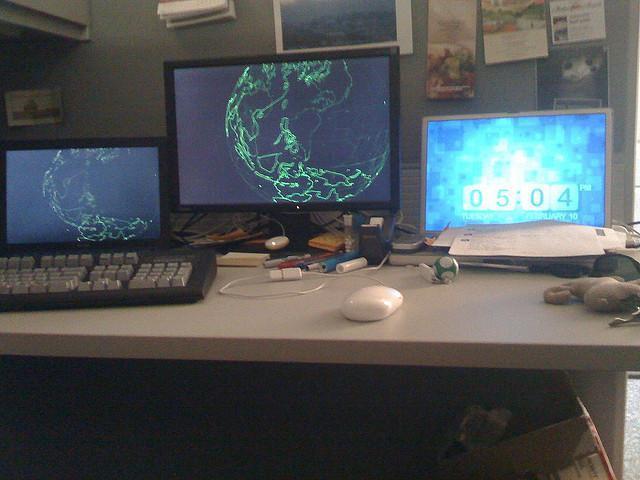How many computer monitors are on this desk?
Give a very brief answer. 3. How many tvs are there?
Give a very brief answer. 3. 